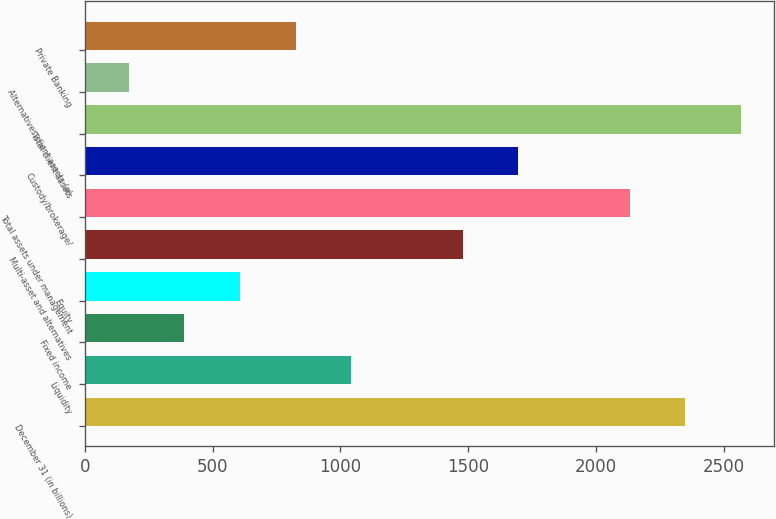Convert chart to OTSL. <chart><loc_0><loc_0><loc_500><loc_500><bar_chart><fcel>December 31 (in billions)<fcel>Liquidity<fcel>Fixed income<fcel>Equity<fcel>Multi-asset and alternatives<fcel>Total assets under management<fcel>Custody/brokerage/<fcel>Total client assets<fcel>Alternatives client assets (a)<fcel>Private Banking<nl><fcel>2350<fcel>1043.2<fcel>389.8<fcel>607.6<fcel>1478.8<fcel>2132.2<fcel>1696.6<fcel>2567.8<fcel>172<fcel>825.4<nl></chart> 